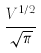<formula> <loc_0><loc_0><loc_500><loc_500>\frac { V ^ { 1 / 2 } } { \sqrt { \pi } }</formula> 